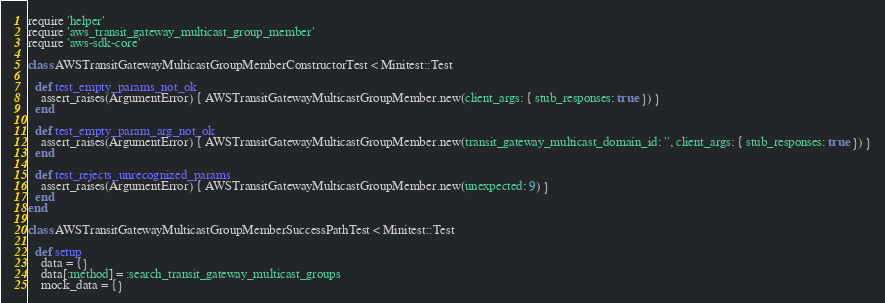Convert code to text. <code><loc_0><loc_0><loc_500><loc_500><_Ruby_>require 'helper'
require 'aws_transit_gateway_multicast_group_member'
require 'aws-sdk-core'

class AWSTransitGatewayMulticastGroupMemberConstructorTest < Minitest::Test

  def test_empty_params_not_ok
    assert_raises(ArgumentError) { AWSTransitGatewayMulticastGroupMember.new(client_args: { stub_responses: true }) }
  end

  def test_empty_param_arg_not_ok
    assert_raises(ArgumentError) { AWSTransitGatewayMulticastGroupMember.new(transit_gateway_multicast_domain_id: '', client_args: { stub_responses: true }) }
  end

  def test_rejects_unrecognized_params
    assert_raises(ArgumentError) { AWSTransitGatewayMulticastGroupMember.new(unexpected: 9) }
  end
end

class AWSTransitGatewayMulticastGroupMemberSuccessPathTest < Minitest::Test

  def setup
    data = {}
    data[:method] = :search_transit_gateway_multicast_groups
    mock_data = {}</code> 